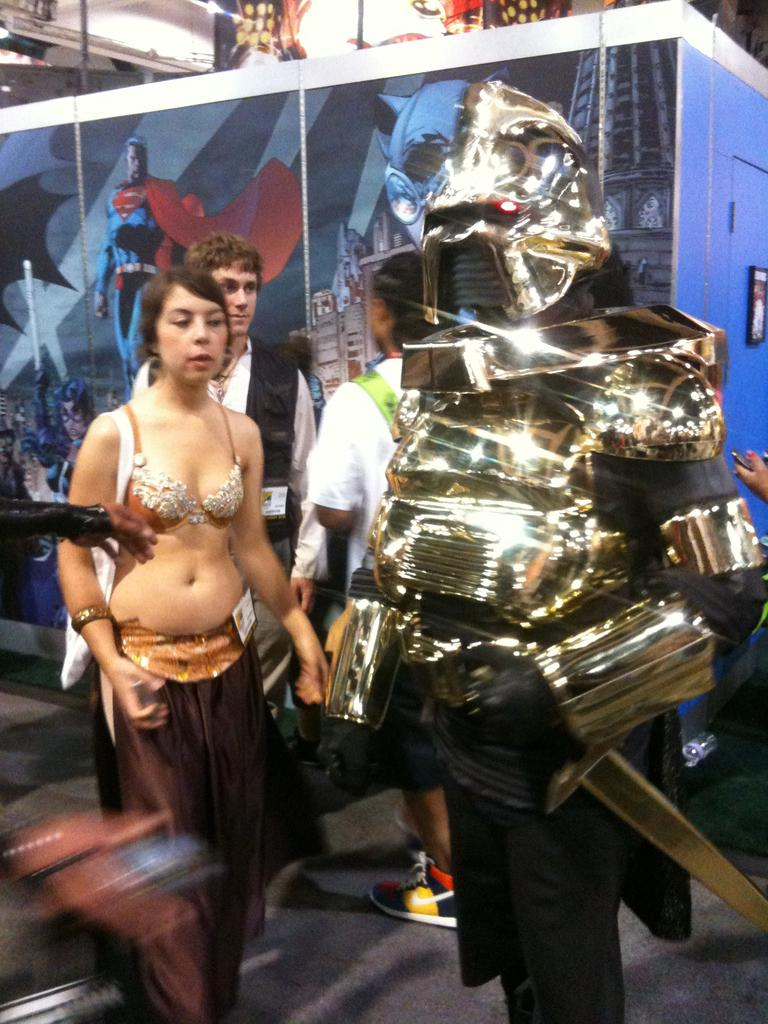What are the people in the image doing? The people in the image are standing on the floor. Can you describe the appearance of one of the people? One person is wearing a costume. What can be seen in the background of the image? There is a wall with a painting in the background of the image. How many dogs are sitting in the basin in the image? There are no dogs or basins present in the image. What type of selection process is being conducted in the image? There is no indication of a selection process in the image. 